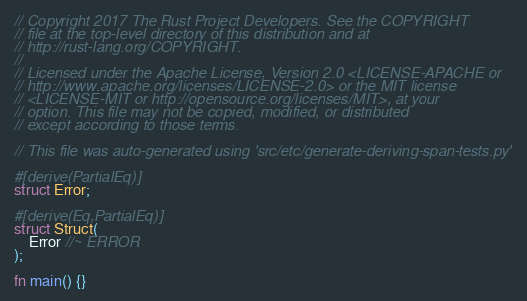<code> <loc_0><loc_0><loc_500><loc_500><_Rust_>// Copyright 2017 The Rust Project Developers. See the COPYRIGHT
// file at the top-level directory of this distribution and at
// http://rust-lang.org/COPYRIGHT.
//
// Licensed under the Apache License, Version 2.0 <LICENSE-APACHE or
// http://www.apache.org/licenses/LICENSE-2.0> or the MIT license
// <LICENSE-MIT or http://opensource.org/licenses/MIT>, at your
// option. This file may not be copied, modified, or distributed
// except according to those terms.

// This file was auto-generated using 'src/etc/generate-deriving-span-tests.py'

#[derive(PartialEq)]
struct Error;

#[derive(Eq,PartialEq)]
struct Struct(
    Error //~ ERROR
);

fn main() {}
</code> 